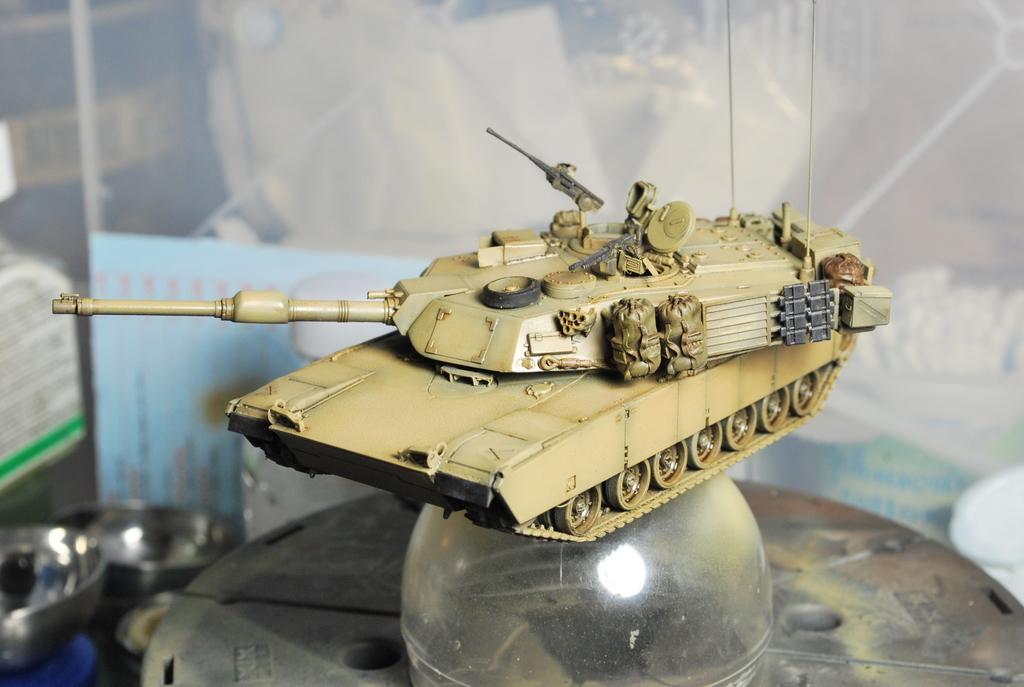In one or two sentences, can you explain what this image depicts? In this image there is a toy army tanks on a glass object , and at the background there is hoarding, steel bowls. 